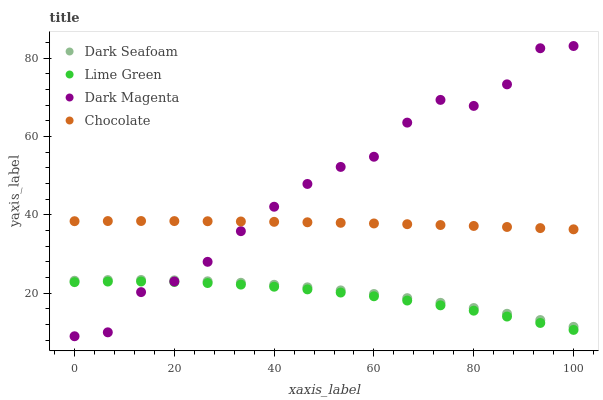Does Lime Green have the minimum area under the curve?
Answer yes or no. Yes. Does Dark Magenta have the maximum area under the curve?
Answer yes or no. Yes. Does Dark Magenta have the minimum area under the curve?
Answer yes or no. No. Does Lime Green have the maximum area under the curve?
Answer yes or no. No. Is Chocolate the smoothest?
Answer yes or no. Yes. Is Dark Magenta the roughest?
Answer yes or no. Yes. Is Lime Green the smoothest?
Answer yes or no. No. Is Lime Green the roughest?
Answer yes or no. No. Does Dark Magenta have the lowest value?
Answer yes or no. Yes. Does Lime Green have the lowest value?
Answer yes or no. No. Does Dark Magenta have the highest value?
Answer yes or no. Yes. Does Lime Green have the highest value?
Answer yes or no. No. Is Lime Green less than Dark Seafoam?
Answer yes or no. Yes. Is Chocolate greater than Dark Seafoam?
Answer yes or no. Yes. Does Dark Magenta intersect Lime Green?
Answer yes or no. Yes. Is Dark Magenta less than Lime Green?
Answer yes or no. No. Is Dark Magenta greater than Lime Green?
Answer yes or no. No. Does Lime Green intersect Dark Seafoam?
Answer yes or no. No. 